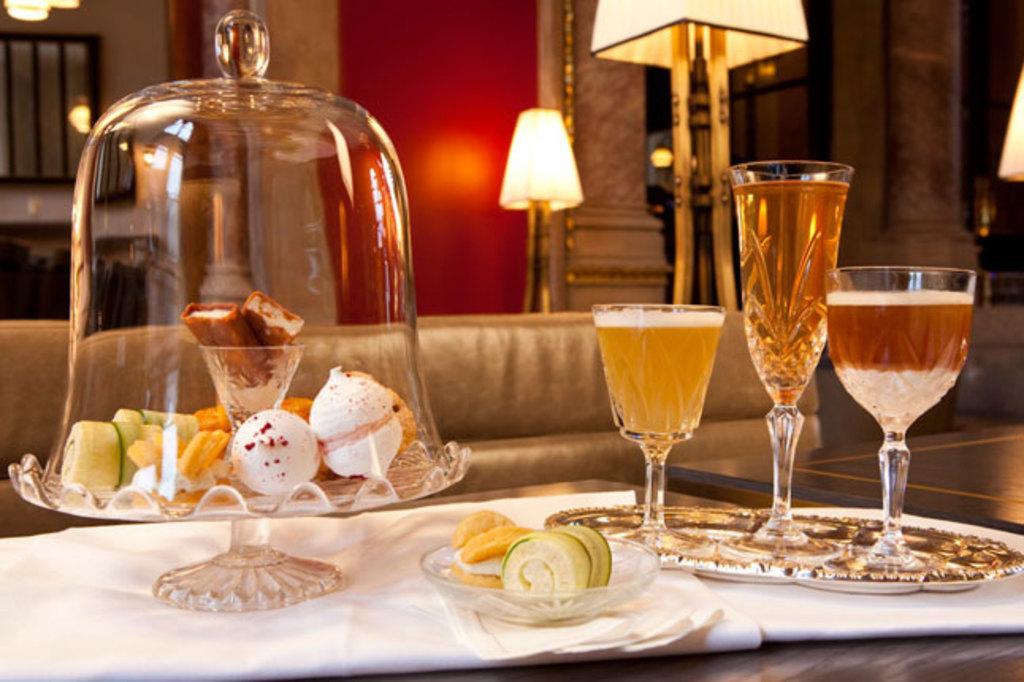In one or two sentences, can you explain what this image depicts? In this picture we can find some deserts placed in a bowl and wine served in glass of different sizes and there is a couch, a lamp is placed behind the couch and there is a red painted wall. 